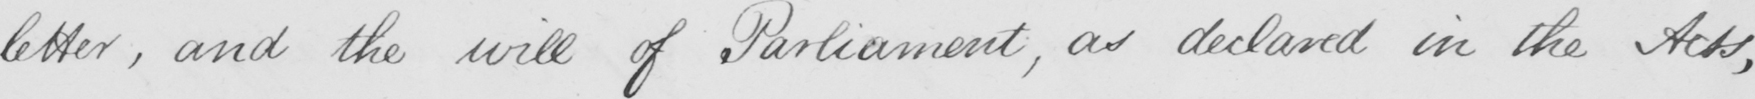Please transcribe the handwritten text in this image. letter , and the will of Parliament , as declared in the Acts , 